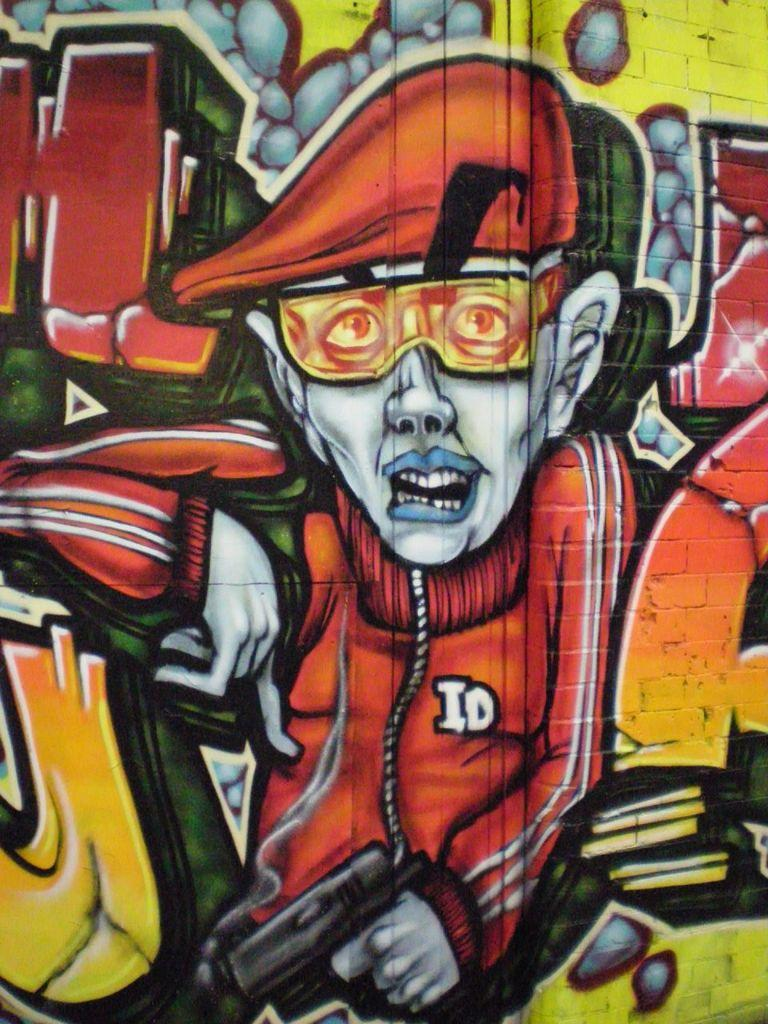What is depicted on the wall in the image? There is a painting of a person on the wall. Can you describe the subject of the painting? The painting features a person, but the specific details of the person cannot be determined from the image alone. What type of drum is being played by the person in the painting? There is no drum present in the painting; it only features a person. 